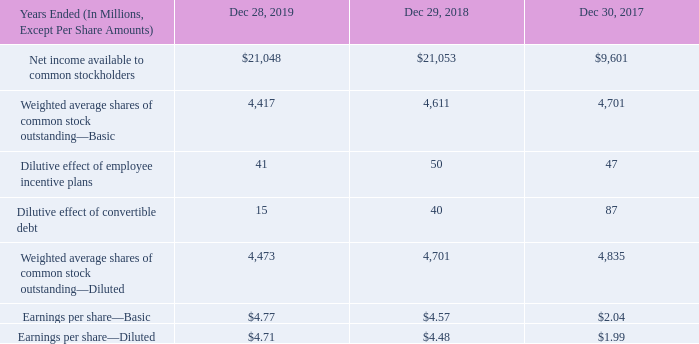NOTE 5: EARNINGS PER SHARE
We computed basic earnings per share of common stock based on the weighted average number of shares of common stock outstanding during the period. We computed diluted earnings per share of common stock based on the weighted average number of shares of common stock outstanding plus potentially dilutive shares of common stock outstanding during the period.
Potentially dilutive shares of common stock from employee incentive plans are determined by applying the treasury stock method to the assumed exercise of outstanding stock options, the assumed vesting of outstanding RSUs, and the assumed issuance of common stock under the 2006 ESPP. In December 2017, we paid cash to satisfy the conversion of our convertible
debentures due 2035, which we excluded from our diluted earnings per share computation starting in the fourth quarter of 2017 and are no longer dilutive. In November 2019, we issued a notice of redemption for the remaining $372 million of 2009 Debentures with a redemption date of January 9, 2020. Our 2009 Debentures required settlement of the principal amount of the debt in cash upon conversion. Since the conversion premium was paid in cash or stock at our option, we determined the potentially dilutive shares of common stock by applying the treasury stock method. We included our 2009 Debentures in the calculation of diluted earnings per share of common stock in all periods presented because the average market price was above the conversion price.
Potentially dilutive shares of common stock from employee incentive plans are determined by applying the treasury stock method to the assumed exercise of outstanding stock options, the assumed vesting of outstanding RSUs, and the assumed issuance of common stock under the 2006 ESPP. In December 2017, we paid cash to satisfy the conversion of our convertible debentures due 2035, which we excluded from our diluted earnings per share computation starting in the fourth quarter of 2017 and are no longer dilutive. In November 2019, we issued a notice of redemption for the remaining $372 million of 2009 Debentures with a redemption date of January 9, 2020. Our 2009 Debentures required settlement of the principal amount of the debt in cash upon conversion. Since the conversion premium was paid in cash or stock at our option, we determined the potentially dilutive shares of common stock by applying the treasury stock method. We included our 2009 Debentures in the calculation of diluted earnings per share of common stock in all periods presented because the average market price was above the conversion price.
Securities that would have been anti-dilutive are insignificant and are excluded from the computation of diluted earnings per share in all periods presented.
What are the basic earnings per share of common stock for the year 2017, 2018 and 2019 respectively? $2.04, $4.57, $4.77. What are the diluted earnings per share of common stock for the year 2017, 2018 and 2019 respectively? $1.99, $4.48, $4.71. How are the potentially dilutive shares of common stock from employee incentive plans determined? By applying the treasury stock method to the assumed exercise of outstanding stock options, the assumed vesting of outstanding rsus, and the assumed issuance of common stock under the 2006 espp. What is the percentage change of basic earnings per share of common stock from 2018 to 2019?
Answer scale should be: percent. (4.77 - 4.57) / 4.57 
Answer: 4.38. On which year does the dilutive effects have the largest impact on diluted earnings per share of common stock? 2019:(41 + 15 = 56); 2018:(50 + 40 = 90); 2017:(47 + 87 = 134)
Answer: 2017. What is the percentage change of net income available to common stockholders from 2017 to 2018?
Answer scale should be: percent. (21,053 - 9,601) / 9,601 
Answer: 119.28. 